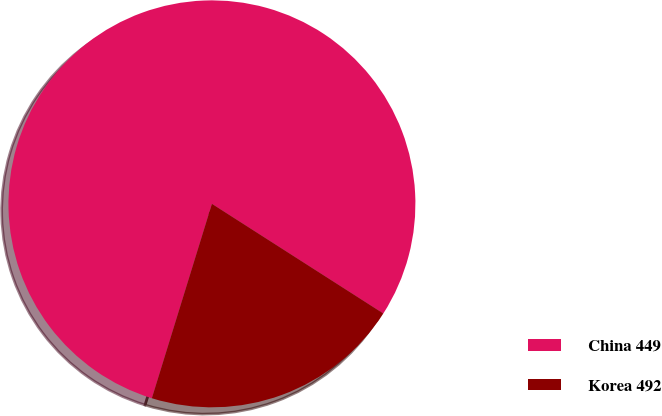Convert chart. <chart><loc_0><loc_0><loc_500><loc_500><pie_chart><fcel>China 449<fcel>Korea 492<nl><fcel>79.29%<fcel>20.71%<nl></chart> 